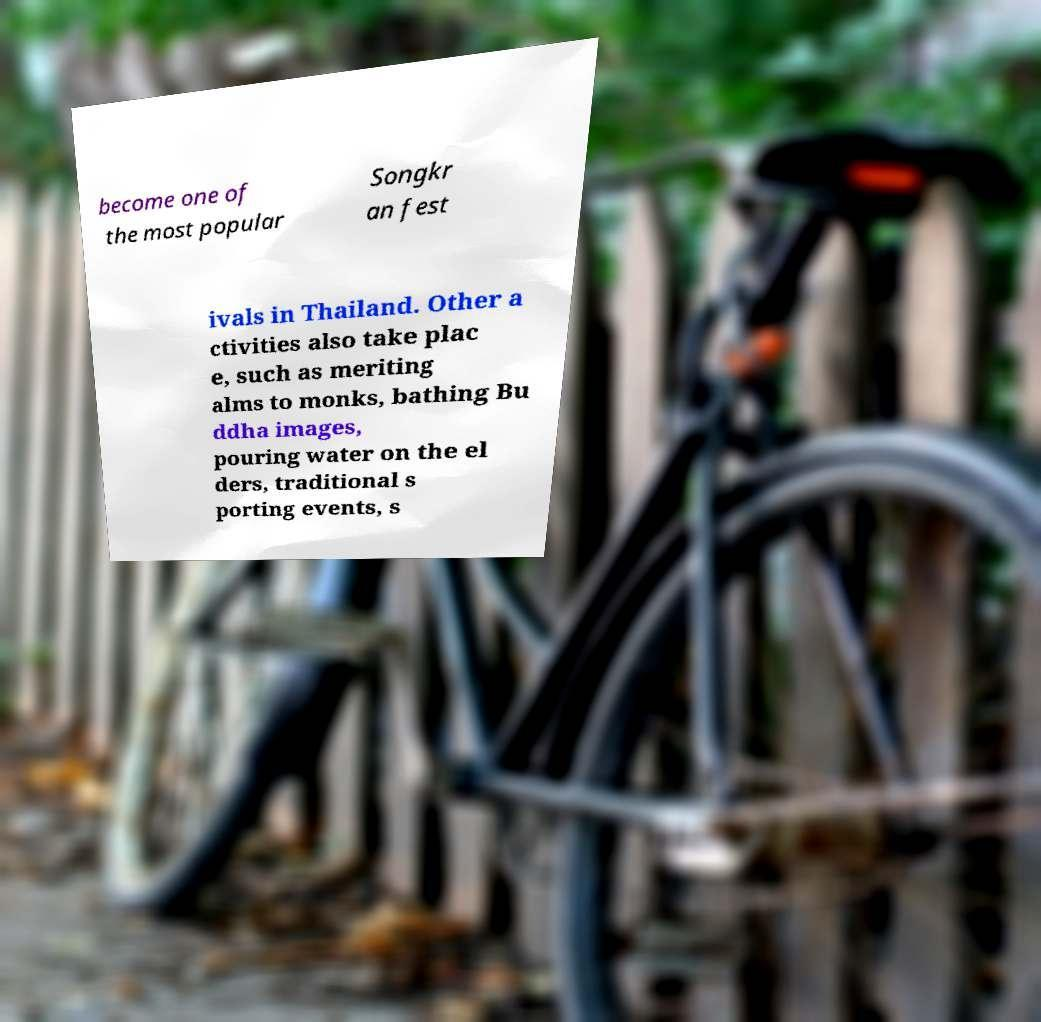Could you extract and type out the text from this image? become one of the most popular Songkr an fest ivals in Thailand. Other a ctivities also take plac e, such as meriting alms to monks, bathing Bu ddha images, pouring water on the el ders, traditional s porting events, s 